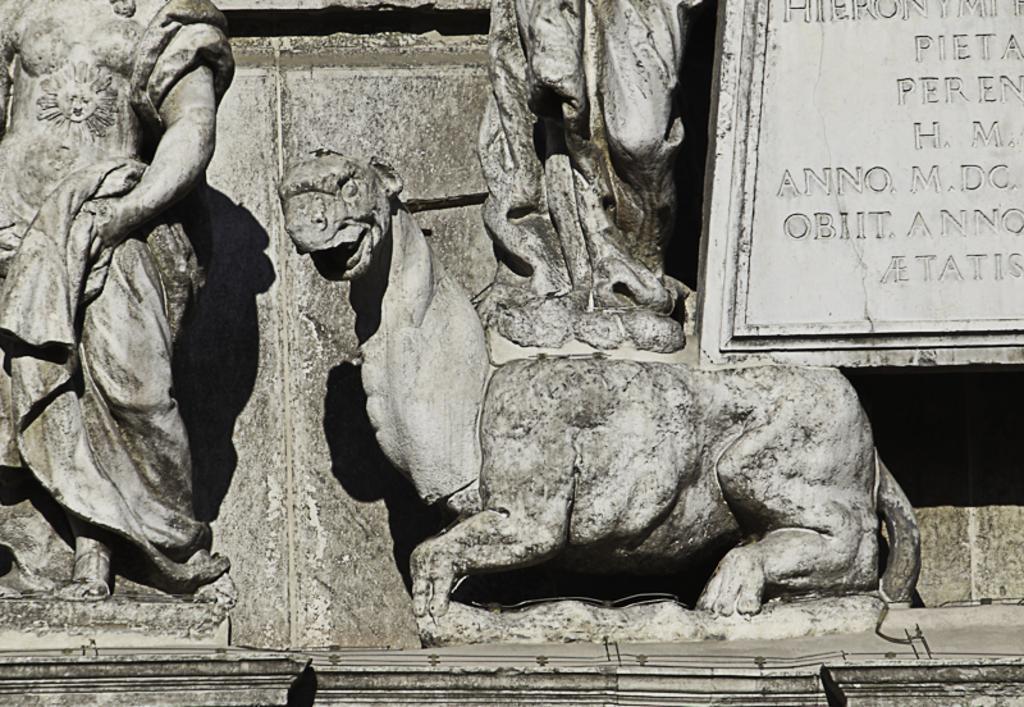Please provide a concise description of this image. In this picture, there are statues towards the left. Towards the right, there is a board and some text engraved on it. 